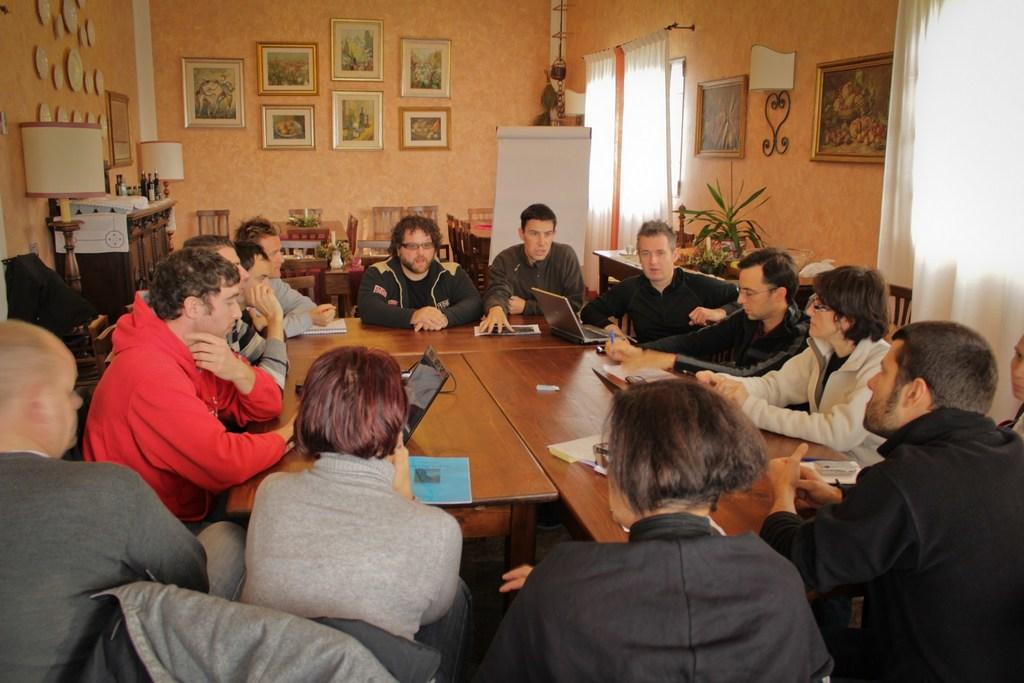How many people are in the image? There is a group of people in the image. What are the people doing in the image? The people are sitting in the image. What is in front of the people? There is a table in front of the people. What electronic device is on the table? A laptop is present on the table. What type of writing materials are on the table? There are pens on the table. What type of paperwork is on the table? There are papers and files on the table. What type of guide is leading the group of people in the image? There is no guide present in the image; the people are sitting and not moving. What type of motion can be seen in the image? There is no motion visible in the image; the people are sitting and the objects on the table are stationary. 